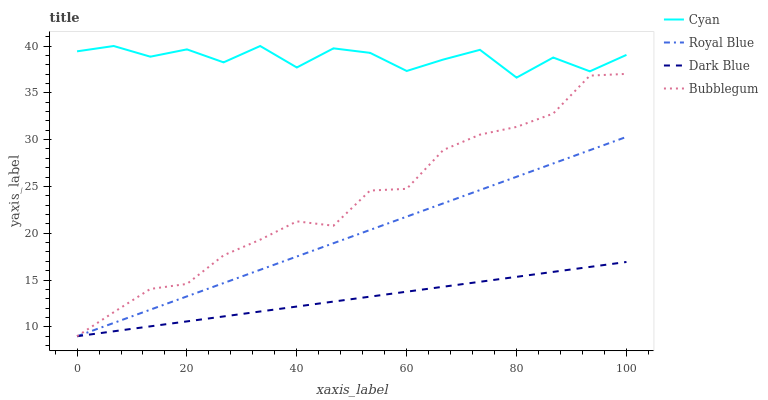Does Dark Blue have the minimum area under the curve?
Answer yes or no. Yes. Does Cyan have the maximum area under the curve?
Answer yes or no. Yes. Does Bubblegum have the minimum area under the curve?
Answer yes or no. No. Does Bubblegum have the maximum area under the curve?
Answer yes or no. No. Is Dark Blue the smoothest?
Answer yes or no. Yes. Is Cyan the roughest?
Answer yes or no. Yes. Is Bubblegum the smoothest?
Answer yes or no. No. Is Bubblegum the roughest?
Answer yes or no. No. Does Dark Blue have the lowest value?
Answer yes or no. Yes. Does Cyan have the highest value?
Answer yes or no. Yes. Does Bubblegum have the highest value?
Answer yes or no. No. Is Dark Blue less than Cyan?
Answer yes or no. Yes. Is Cyan greater than Royal Blue?
Answer yes or no. Yes. Does Dark Blue intersect Royal Blue?
Answer yes or no. Yes. Is Dark Blue less than Royal Blue?
Answer yes or no. No. Is Dark Blue greater than Royal Blue?
Answer yes or no. No. Does Dark Blue intersect Cyan?
Answer yes or no. No. 